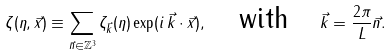Convert formula to latex. <formula><loc_0><loc_0><loc_500><loc_500>\zeta ( \eta , \vec { x } ) \equiv \sum _ { \vec { n } \in \mathbb { Z } ^ { 3 } } \zeta _ { \vec { k } } ( \eta ) \exp ( i \, \vec { k } \cdot \vec { x } ) , \quad \text {with} \quad \vec { k } = \frac { 2 \pi } { L } \vec { n } .</formula> 